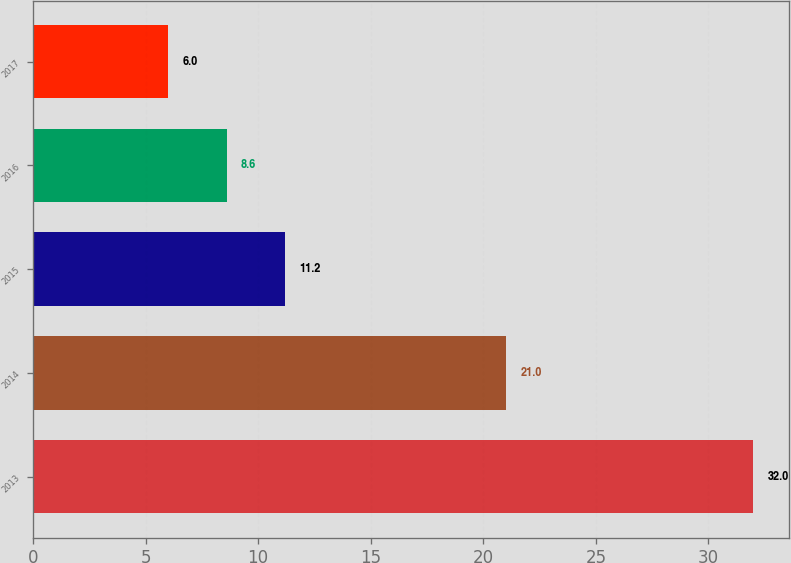Convert chart to OTSL. <chart><loc_0><loc_0><loc_500><loc_500><bar_chart><fcel>2013<fcel>2014<fcel>2015<fcel>2016<fcel>2017<nl><fcel>32<fcel>21<fcel>11.2<fcel>8.6<fcel>6<nl></chart> 